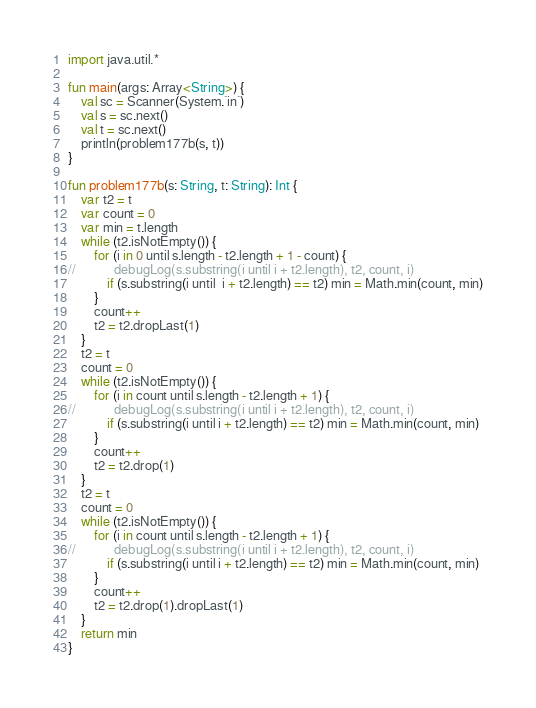<code> <loc_0><loc_0><loc_500><loc_500><_Kotlin_>import java.util.*

fun main(args: Array<String>) {
    val sc = Scanner(System.`in`)
    val s = sc.next()
    val t = sc.next()
    println(problem177b(s, t))
}

fun problem177b(s: String, t: String): Int {
    var t2 = t
    var count = 0
    var min = t.length
    while (t2.isNotEmpty()) {
        for (i in 0 until s.length - t2.length + 1 - count) {
//            debugLog(s.substring(i until i + t2.length), t2, count, i)
            if (s.substring(i until  i + t2.length) == t2) min = Math.min(count, min)
        }
        count++
        t2 = t2.dropLast(1)
    }
    t2 = t
    count = 0
    while (t2.isNotEmpty()) {
        for (i in count until s.length - t2.length + 1) {
//            debugLog(s.substring(i until i + t2.length), t2, count, i)
            if (s.substring(i until i + t2.length) == t2) min = Math.min(count, min)
        }
        count++
        t2 = t2.drop(1)
    }
    t2 = t
    count = 0
    while (t2.isNotEmpty()) {
        for (i in count until s.length - t2.length + 1) {
//            debugLog(s.substring(i until i + t2.length), t2, count, i)
            if (s.substring(i until i + t2.length) == t2) min = Math.min(count, min)
        }
        count++
        t2 = t2.drop(1).dropLast(1)
    }
    return min
}</code> 